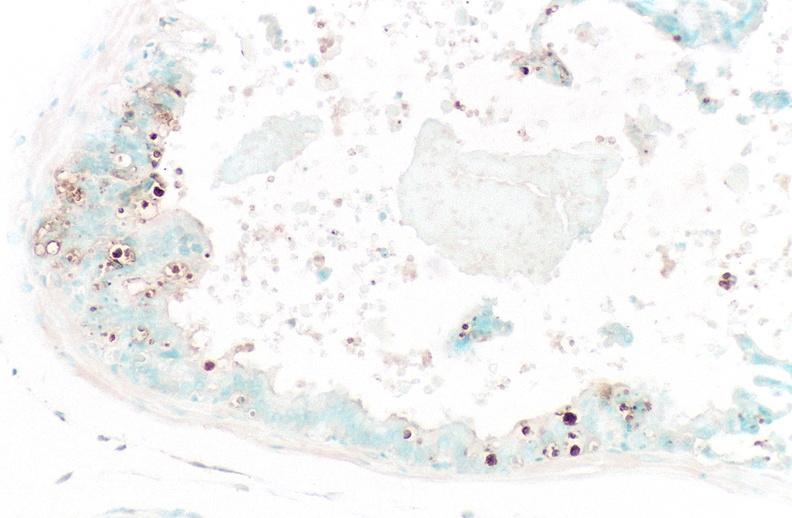does this image show prostate?
Answer the question using a single word or phrase. Yes 